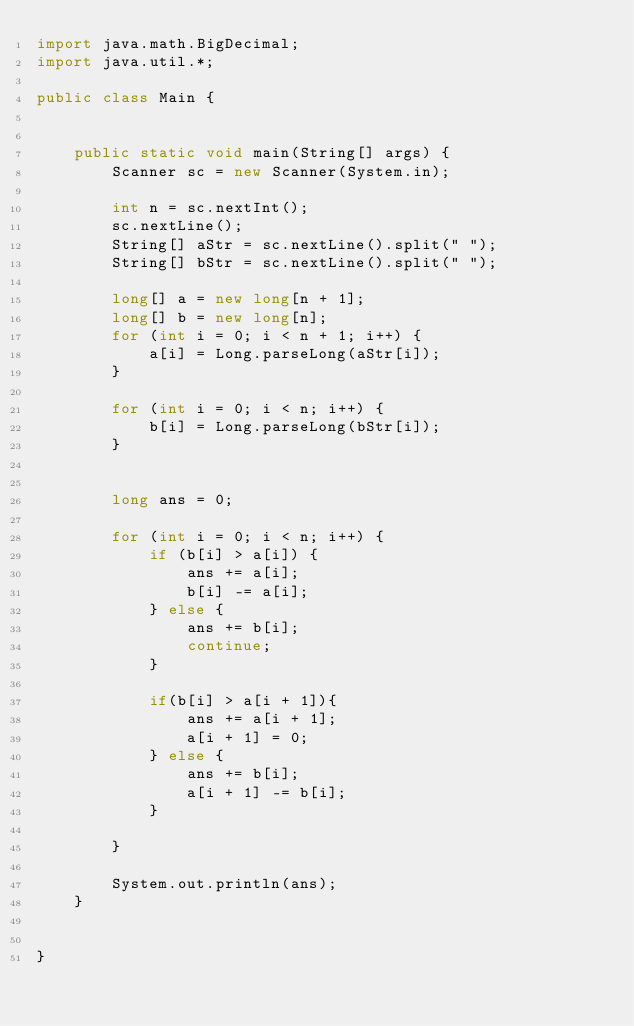Convert code to text. <code><loc_0><loc_0><loc_500><loc_500><_Java_>import java.math.BigDecimal;
import java.util.*;

public class Main {


    public static void main(String[] args) {
        Scanner sc = new Scanner(System.in);

        int n = sc.nextInt();
        sc.nextLine();
        String[] aStr = sc.nextLine().split(" ");
        String[] bStr = sc.nextLine().split(" ");

        long[] a = new long[n + 1];
        long[] b = new long[n];
        for (int i = 0; i < n + 1; i++) {
            a[i] = Long.parseLong(aStr[i]);
        }

        for (int i = 0; i < n; i++) {
            b[i] = Long.parseLong(bStr[i]);
        }


        long ans = 0;

        for (int i = 0; i < n; i++) {
            if (b[i] > a[i]) {
                ans += a[i];
                b[i] -= a[i];
            } else {
                ans += b[i];
                continue;
            }

            if(b[i] > a[i + 1]){
                ans += a[i + 1];
                a[i + 1] = 0;
            } else {
                ans += b[i];
                a[i + 1] -= b[i];
            }

        }

        System.out.println(ans);
    }


}
</code> 